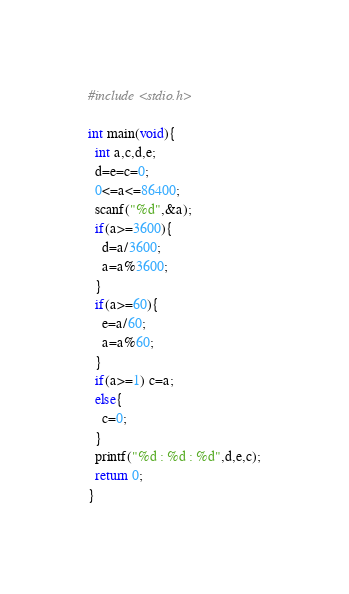Convert code to text. <code><loc_0><loc_0><loc_500><loc_500><_C_>#include <stdio.h>

int main(void){
  int a,c,d,e;
  d=e=c=0;
  0<=a<=86400;
  scanf("%d",&a);
  if(a>=3600){
    d=a/3600;
    a=a%3600;
  }
  if(a>=60){
    e=a/60;
    a=a%60;
  }
  if(a>=1) c=a;
  else{
    c=0;
  }
  printf("%d : %d : %d",d,e,c);
  return 0;
}</code> 